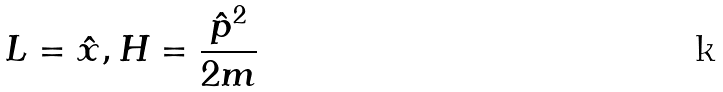Convert formula to latex. <formula><loc_0><loc_0><loc_500><loc_500>L = \hat { x } , H = \frac { \hat { p } ^ { 2 } } { 2 m }</formula> 